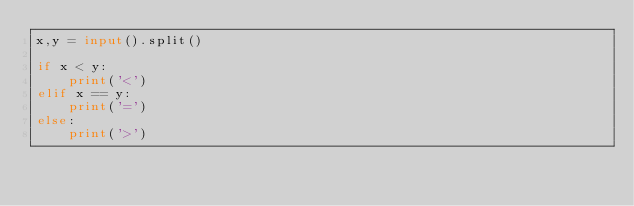<code> <loc_0><loc_0><loc_500><loc_500><_Python_>x,y = input().split()

if x < y:
    print('<')
elif x == y:
    print('=')
else:
    print('>')
</code> 